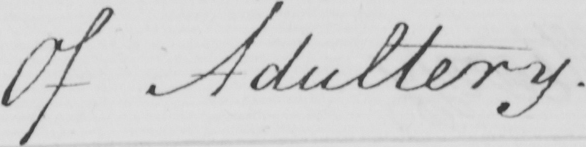Please transcribe the handwritten text in this image. Of Adultery . 